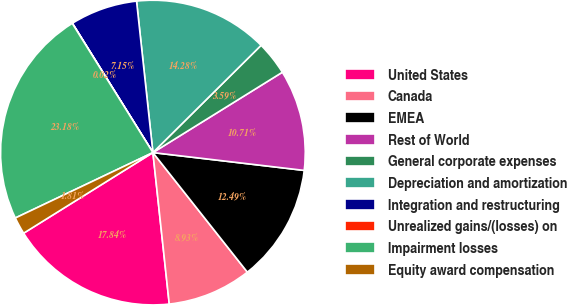<chart> <loc_0><loc_0><loc_500><loc_500><pie_chart><fcel>United States<fcel>Canada<fcel>EMEA<fcel>Rest of World<fcel>General corporate expenses<fcel>Depreciation and amortization<fcel>Integration and restructuring<fcel>Unrealized gains/(losses) on<fcel>Impairment losses<fcel>Equity award compensation<nl><fcel>17.84%<fcel>8.93%<fcel>12.49%<fcel>10.71%<fcel>3.59%<fcel>14.28%<fcel>7.15%<fcel>0.02%<fcel>23.18%<fcel>1.81%<nl></chart> 